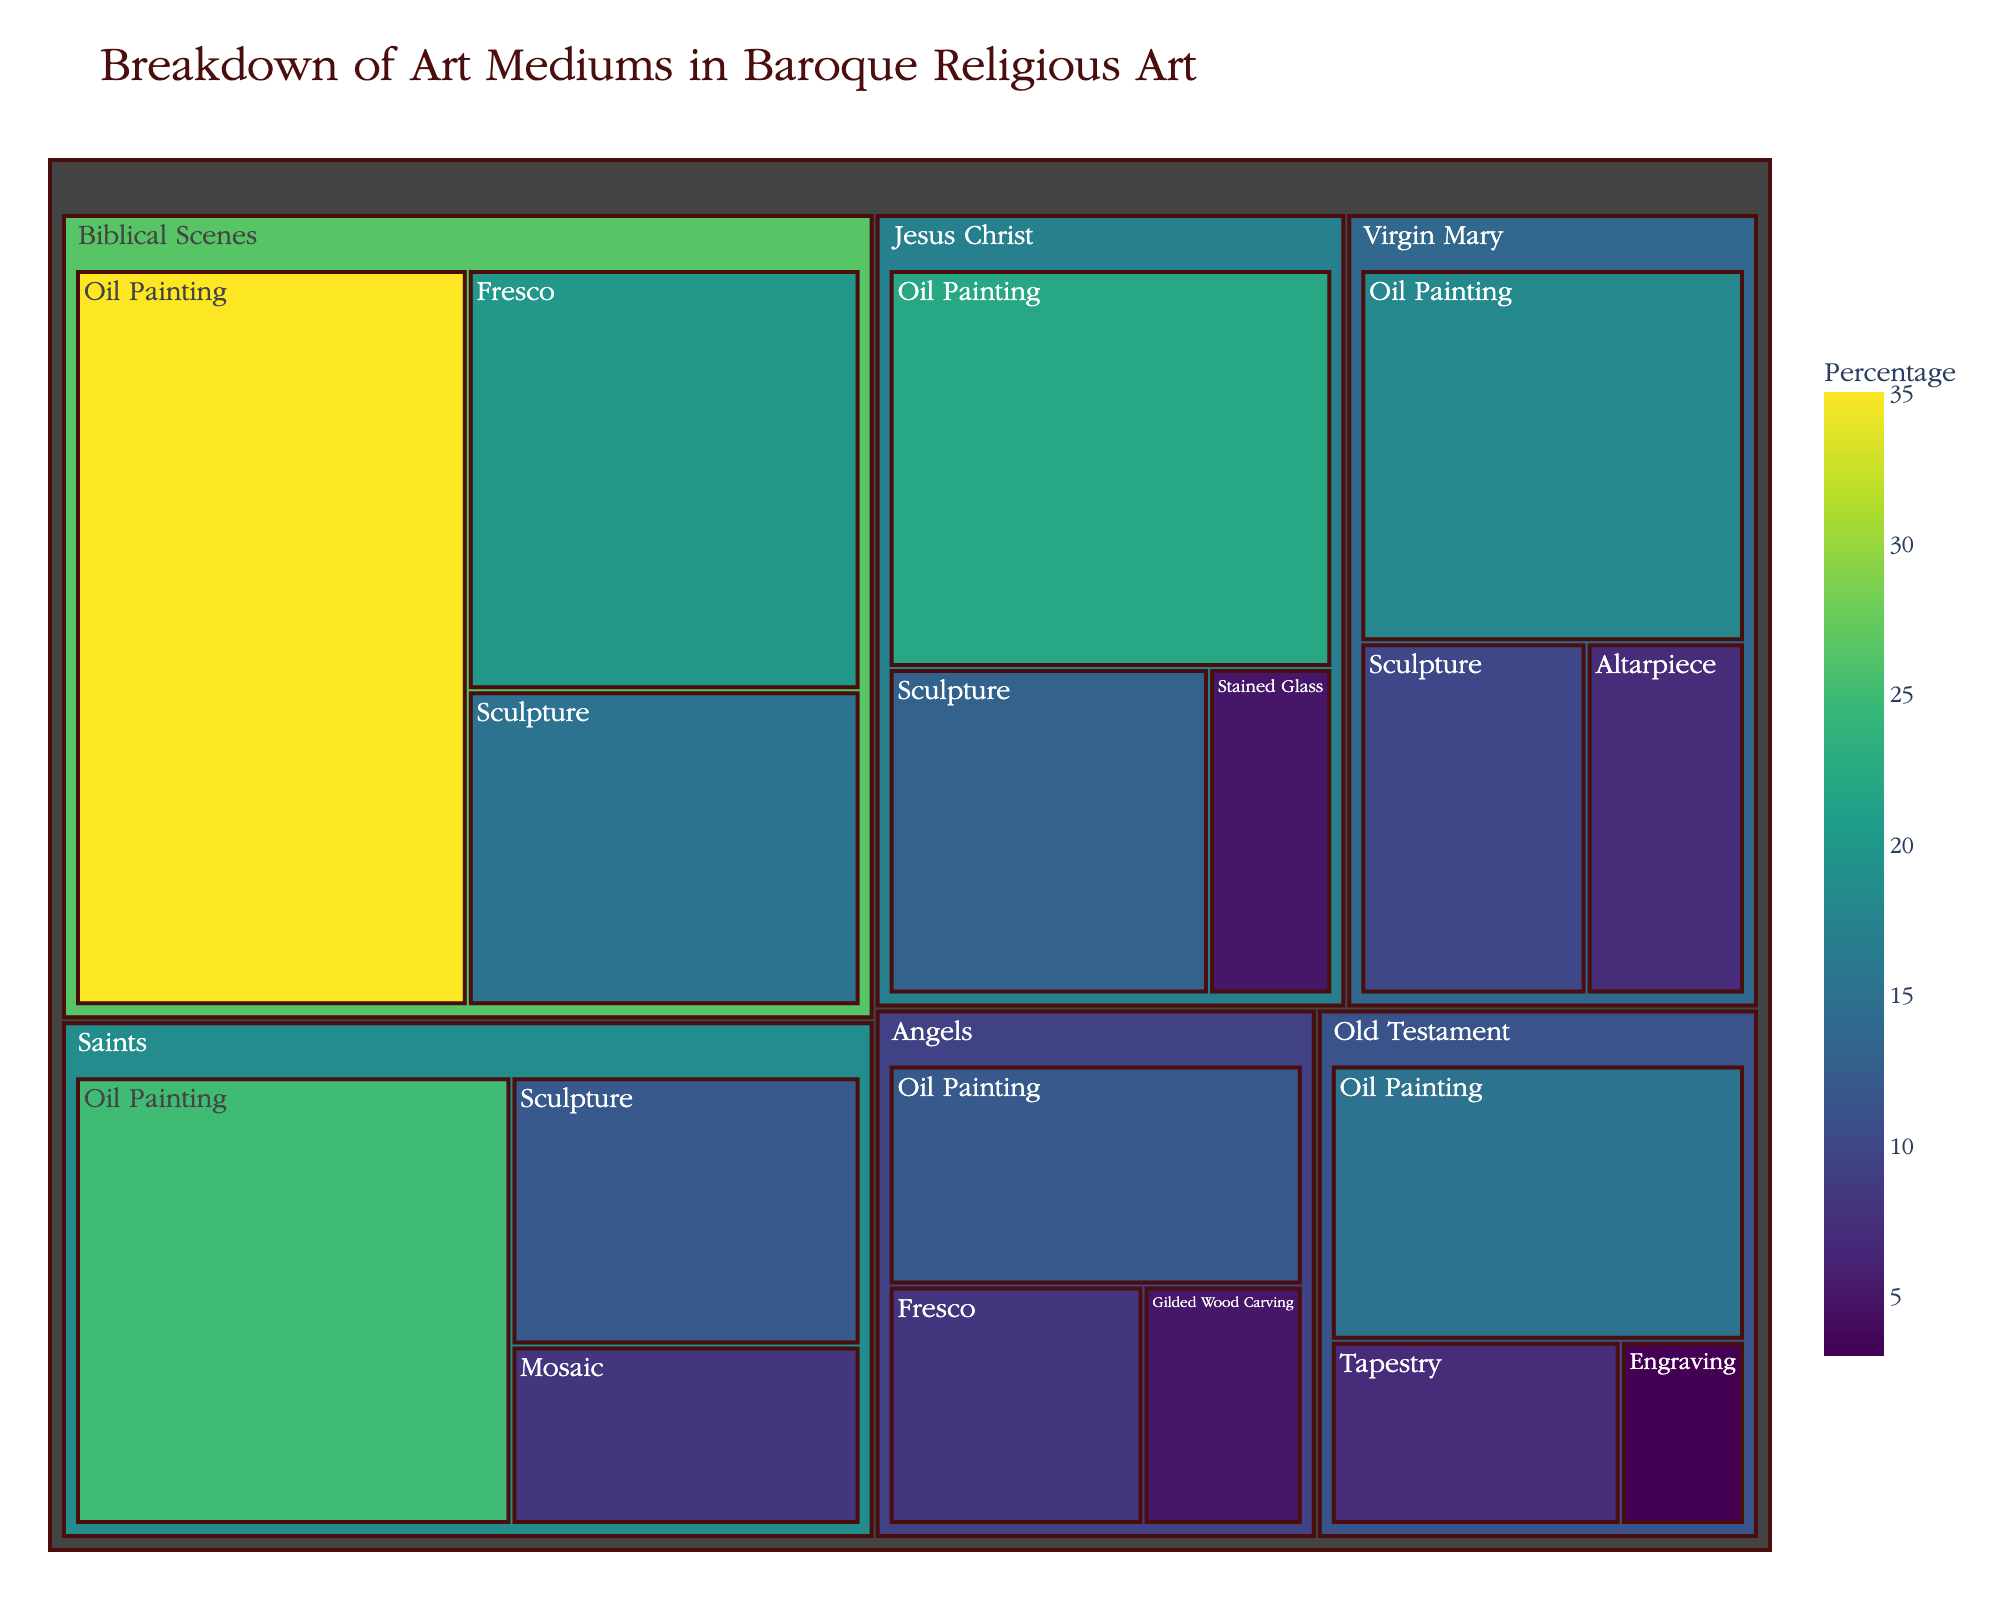What is the largest category in terms of percentage? Look at the different sections of the treemap and determine which one has the highest percentage. The category "Biblical Scenes" with "Oil Painting" covers the most space, accounting for 35%.
Answer: Biblical Scenes - Oil Painting How many medium categories are there under the subject matter “Jesus Christ”? Count the number of unique medium categories listed under "Jesus Christ". They include "Oil Painting", "Sculpture", and "Stained Glass", totaling 3.
Answer: 3 Which medium is used the least for "Old Testament"? Under the "Old Testament" subject matter, check the percentages of the mediums. "Engraving" has the smallest percentage, which is 3%.
Answer: Engraving What is the combined percentage of "Sculpture" in all subject matters? Add the percentages of "Sculpture" across all categories: Biblical Scenes (15%), Saints (12%), Virgin Mary (10%), and Jesus Christ (13%). Summing them gives 15 + 12 + 10 + 13 = 50%.
Answer: 50% Which subject matter has the highest diversity in mediums used? Examine the number of different mediums under each subject matter. “Old Testament” uses 3 different mediums and “Jesus Christ” uses 3 as well. Initially, let's note that the quantity across various subjects appears equal. Looking closely, “Biblical Scenes” uses the highest diversity with 3 mediums and the highest percentage allocation within those mediums.
Answer: Biblical Scenes Compare the use of "Fresco" between "Biblical Scenes" and "Angels". Look at the percentages under "Fresco" for both categories. "Biblical Scenes" uses 20% while "Angels" uses 8%. So, "Biblical Scenes" uses more "Fresco" than "Angels".
Answer: Biblical Scenes What proportion of the total percentage is occupied by "Saints" subject matter across all mediums? Add up the percentages of all mediums under "Saints": Oil Painting (25%), Sculpture (12%), and Mosaic (8%). This gives 25 + 12 + 8 = 45%.
Answer: 45% Which subject matter does "Tapestry" belong to, and what percentage does it represent? Look for the medium "Tapestry" and identify its subject matter and percentage. "Tapestry" is used under "Old Testament" and represents 7%.
Answer: Old Testament, 7% How does the percentage of "Oil Painting" for "Virgin Mary" compare to that of "Jesus Christ"? Check the percentage of "Oil Painting" for both subject matters. "Virgin Mary" has 18% while "Jesus Christ" has 22%, so "Jesus Christ" has a higher percentage.
Answer: Jesus Christ What is the total percentage of "Stained Glass" medium across all subject matters? Find the percentages of "Stained Glass". It is only listed under "Jesus Christ" with 5%.
Answer: 5% 